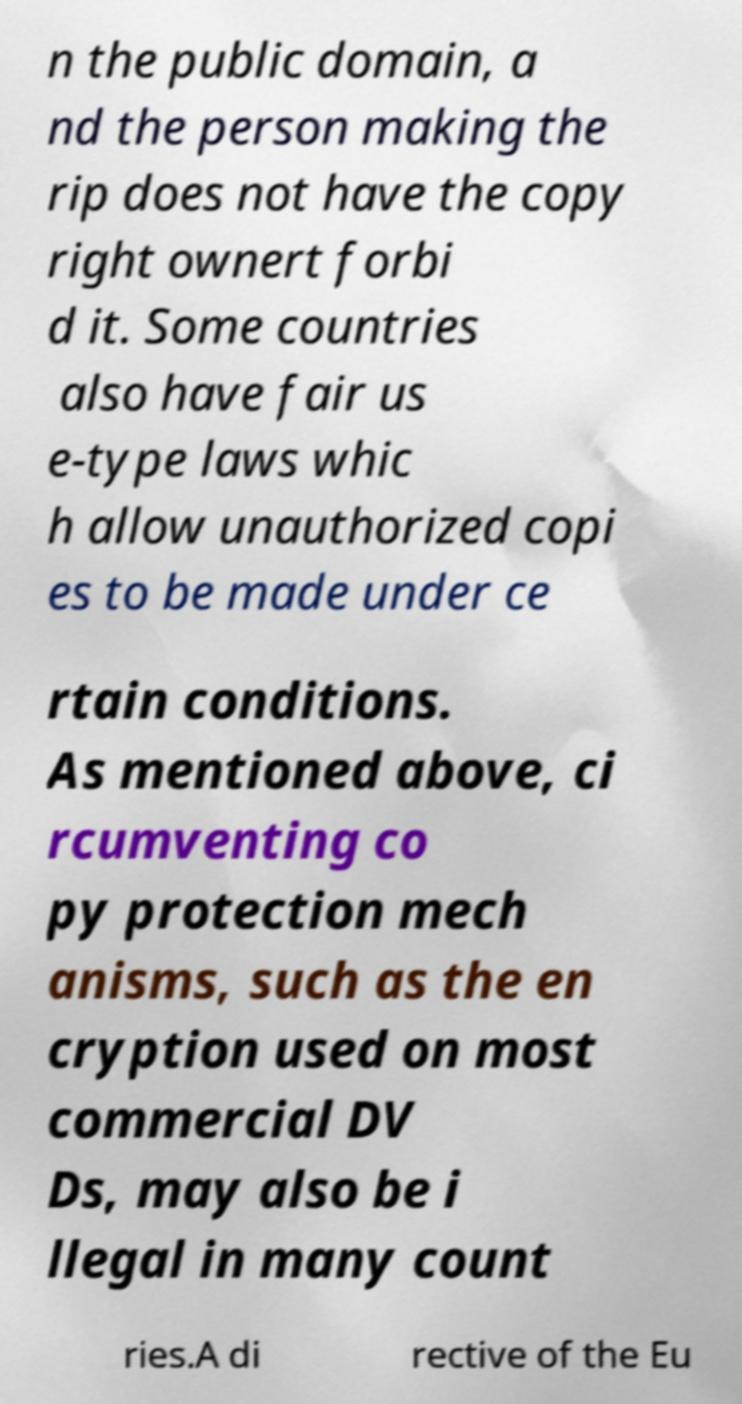What messages or text are displayed in this image? I need them in a readable, typed format. n the public domain, a nd the person making the rip does not have the copy right ownert forbi d it. Some countries also have fair us e-type laws whic h allow unauthorized copi es to be made under ce rtain conditions. As mentioned above, ci rcumventing co py protection mech anisms, such as the en cryption used on most commercial DV Ds, may also be i llegal in many count ries.A di rective of the Eu 